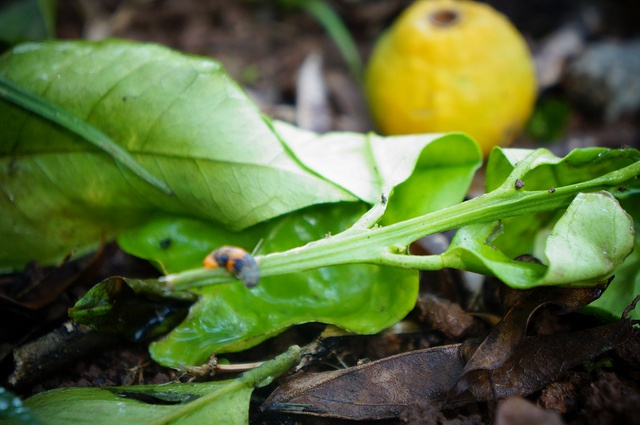Describe the objects in this image and their specific colors. I can see a orange in black, gold, khaki, and olive tones in this image. 